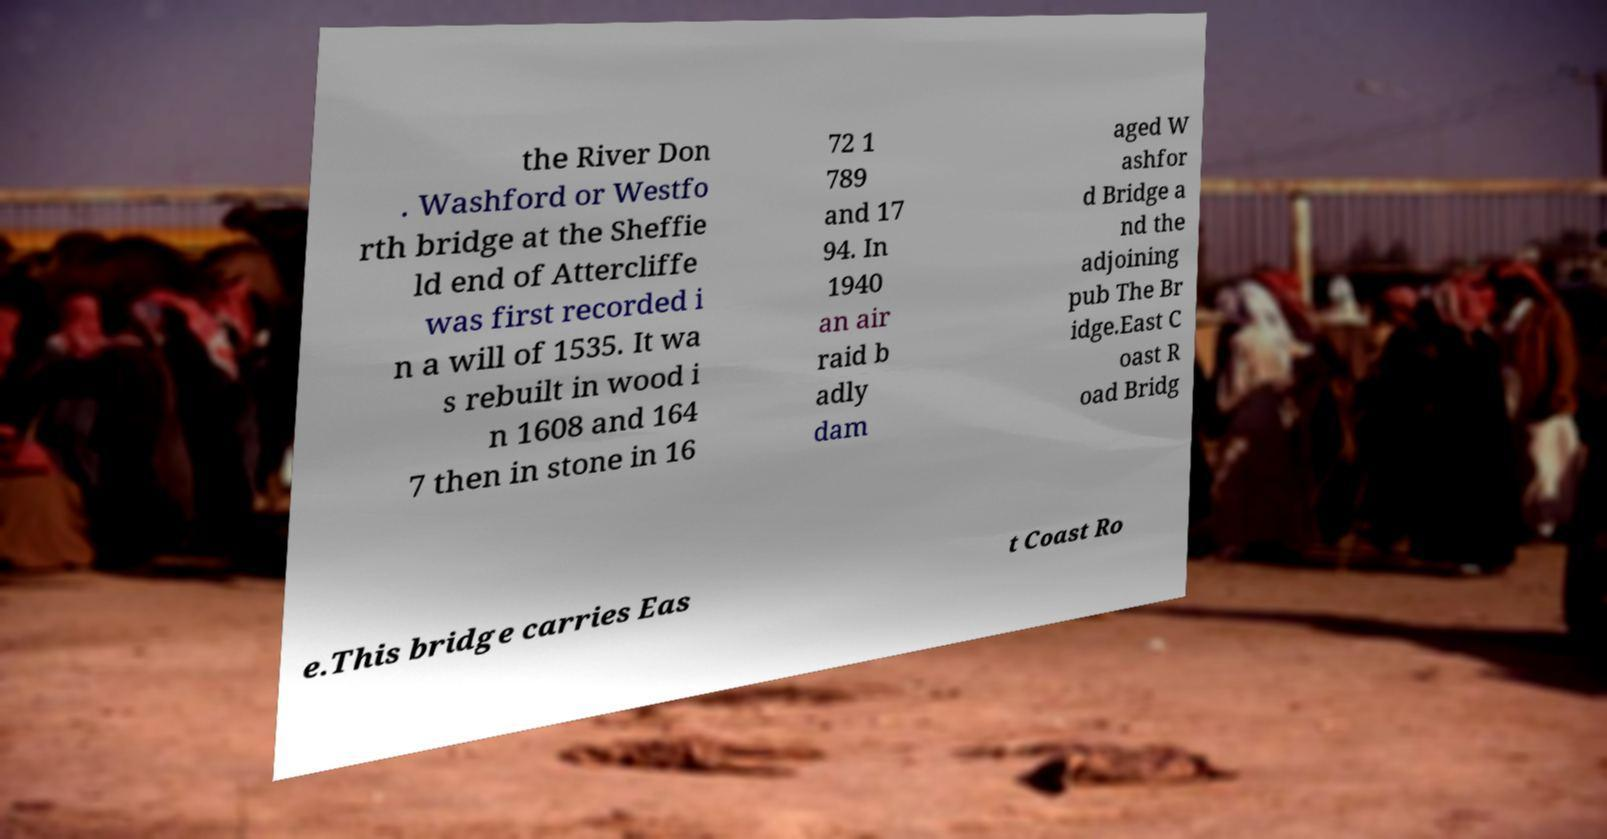Can you read and provide the text displayed in the image?This photo seems to have some interesting text. Can you extract and type it out for me? the River Don . Washford or Westfo rth bridge at the Sheffie ld end of Attercliffe was first recorded i n a will of 1535. It wa s rebuilt in wood i n 1608 and 164 7 then in stone in 16 72 1 789 and 17 94. In 1940 an air raid b adly dam aged W ashfor d Bridge a nd the adjoining pub The Br idge.East C oast R oad Bridg e.This bridge carries Eas t Coast Ro 